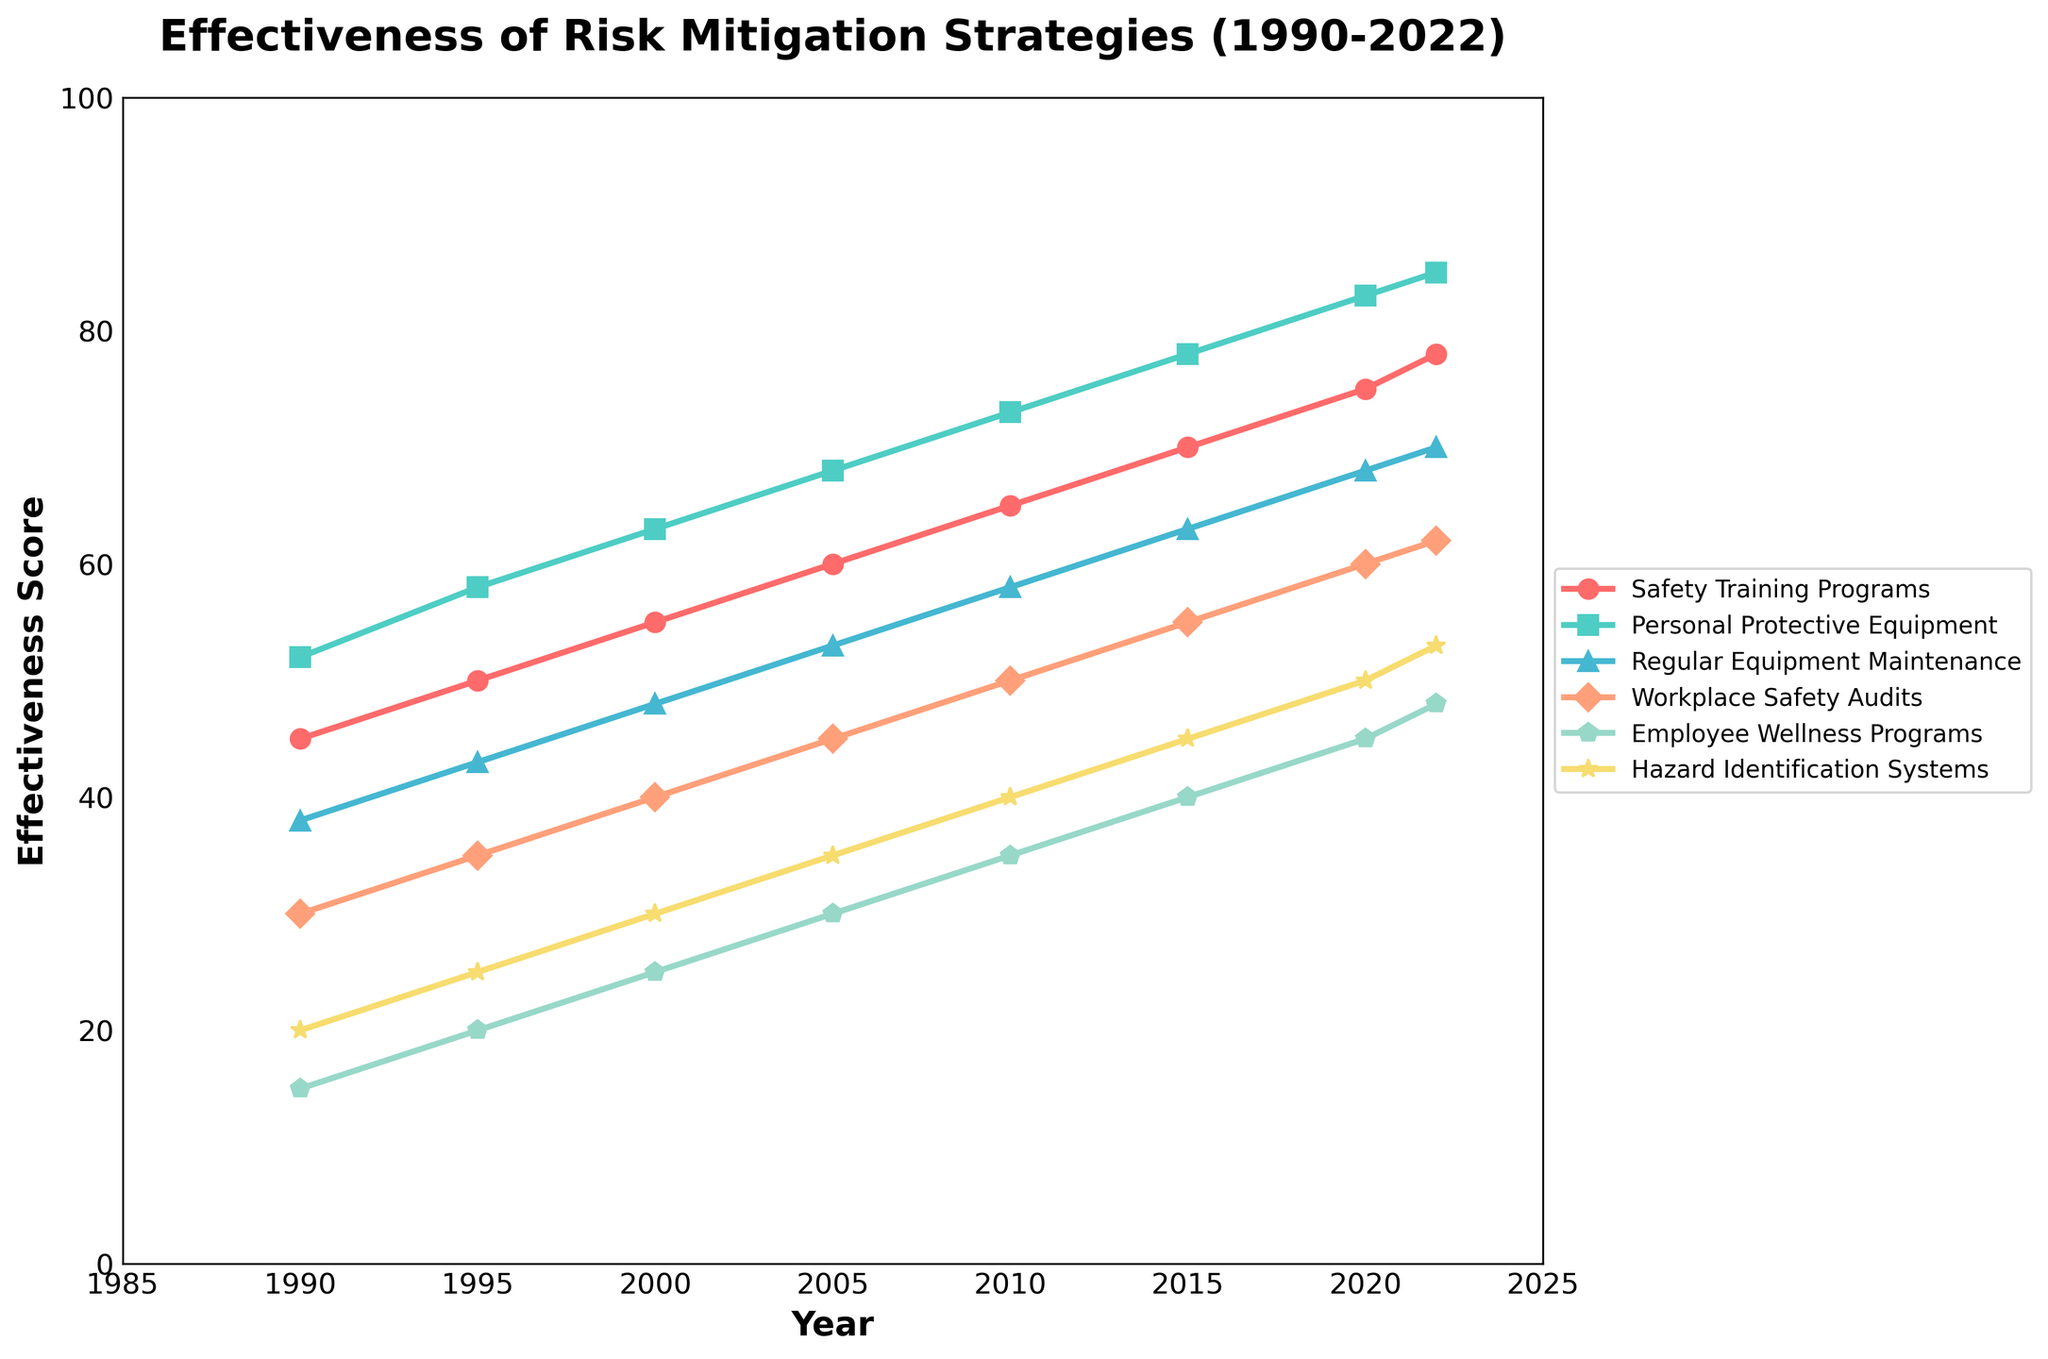Which risk mitigation strategy had the highest effectiveness score in 2022? Look at the endpoint values of each line in 2022 and identify the strategy with the maximum score, which is 85 for Personal Protective Equipment.
Answer: Personal Protective Equipment How has the effectiveness score for Safety Training Programs changed from 1990 to 2022? Subtract the effectiveness score in 1990 (45) from the effectiveness score in 2022 (78). The change is 78 - 45 = 33.
Answer: Increased by 33 Which strategy showed a consistent increase in effectiveness score over the years? Look at the trend lines for each strategy and identify those with a steady upward trend. All strategies show a consistent increase, but a specific answer could be Personal Protective Equipment.
Answer: Personal Protective Equipment Between 2000 and 2022, which strategy had the smallest total increase in effectiveness score? Calculate the difference between the effectiveness scores in 2000 and in 2022 for each strategy, then find the smallest difference. Employee Wellness Programs had the smallest increase: 48 - 25 = 23.
Answer: Employee Wellness Programs What is the difference in effectiveness scores between Safety Training Programs and Regular Equipment Maintenance in 2010? Look at the effectiveness scores for both strategies in 2010: Safety Training Programs (65) and Regular Equipment Maintenance (58). Subtract the smaller value from the larger value: 65 - 58 = 7
Answer: 7 Which two strategies show similar trends over the years but have different effectiveness scores? By comparing the visual trends (shapes of the lines) over time, Safety Training Programs and Personal Protective Equipment show similar trends but different scores.
Answer: Safety Training Programs and Personal Protective Equipment What was the average effectiveness score of Hazard Identification Systems from 1990 to 2022? Sum the effectiveness scores of Hazard Identification Systems from 1990 (20), 1995 (25), 2000 (30), 2005 (35), 2010 (40), 2015 (45), 2020 (50), and 2022 (53) and divide by the number of years. The sum is 298, average is 298/8 = 37.25.
Answer: 37.25 How does the rate of increase for Employee Wellness Programs compare to Safety Training Programs from 2000 to 2020? Calculate the increase for Employee Wellness Programs from 2000 (25) to 2020 (45): 45 - 25 = 20. Calculate the increase for Safety Training Programs from 2000 (55) to 2020 (75): 75 - 55 = 20. Both strategies had the same increase rate.
Answer: Both had the same increase of 20 What year did Workplace Safety Audits surpass an effectiveness score of 50? Examine the trend line for Workplace Safety Audits and find the year when it first exceeded 50, which is 2010.
Answer: 2010 Which two strategies had their effectiveness scores closest to each other in 2022? Compare the effectiveness scores of all strategies in 2022 and find the smallest difference. Regular Equipment Maintenance (70) and Workplace Safety Audits (62) have a difference of 8, which is the smallest observable.
Answer: Regular Equipment Maintenance and Workplace Safety Audits 